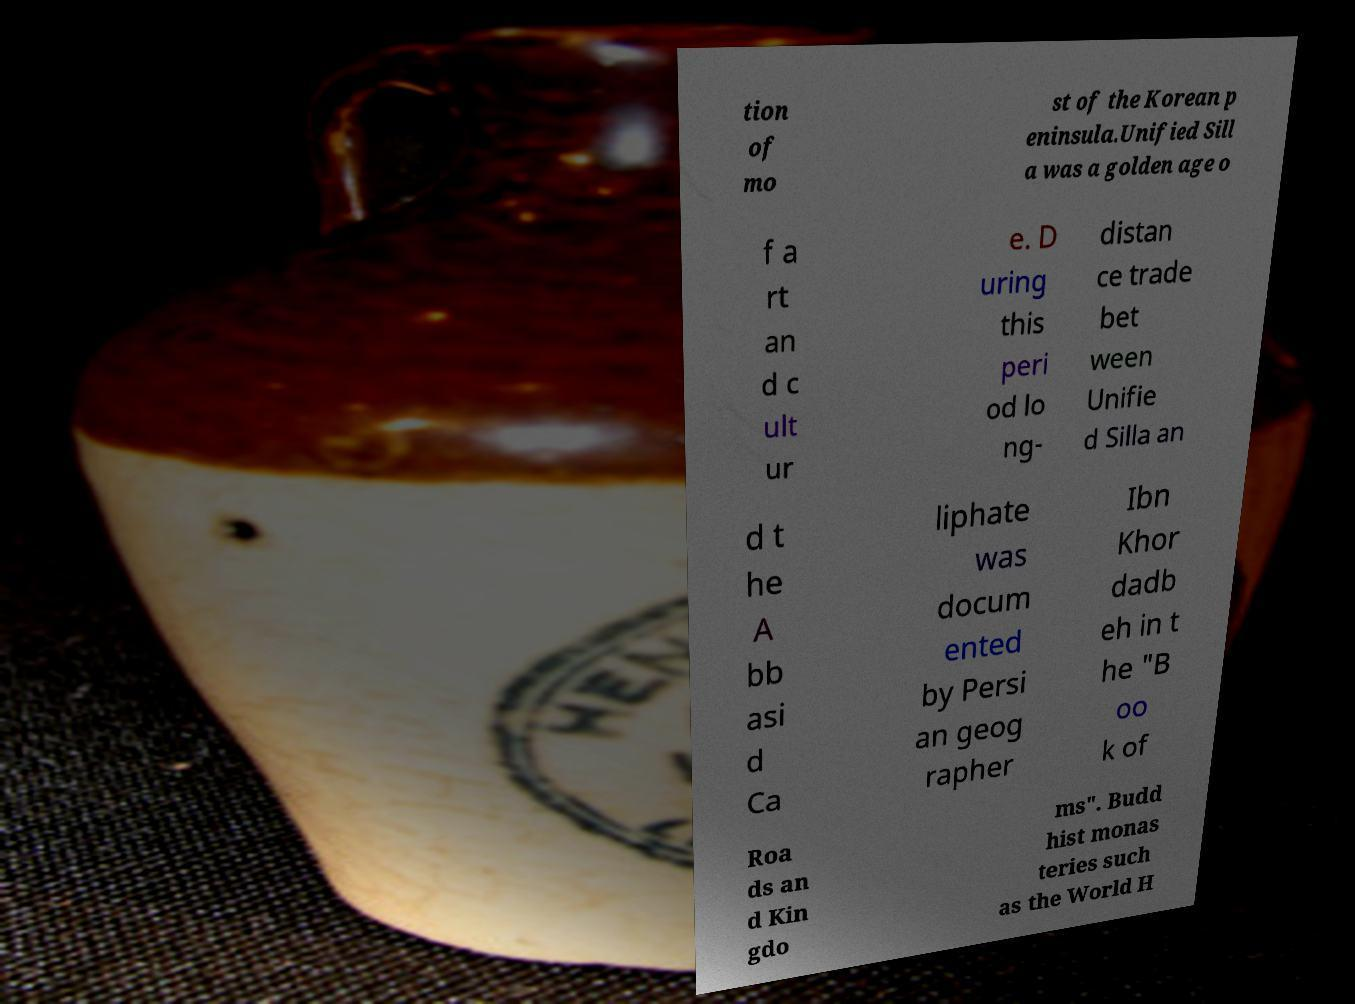Please identify and transcribe the text found in this image. tion of mo st of the Korean p eninsula.Unified Sill a was a golden age o f a rt an d c ult ur e. D uring this peri od lo ng- distan ce trade bet ween Unifie d Silla an d t he A bb asi d Ca liphate was docum ented by Persi an geog rapher Ibn Khor dadb eh in t he "B oo k of Roa ds an d Kin gdo ms". Budd hist monas teries such as the World H 